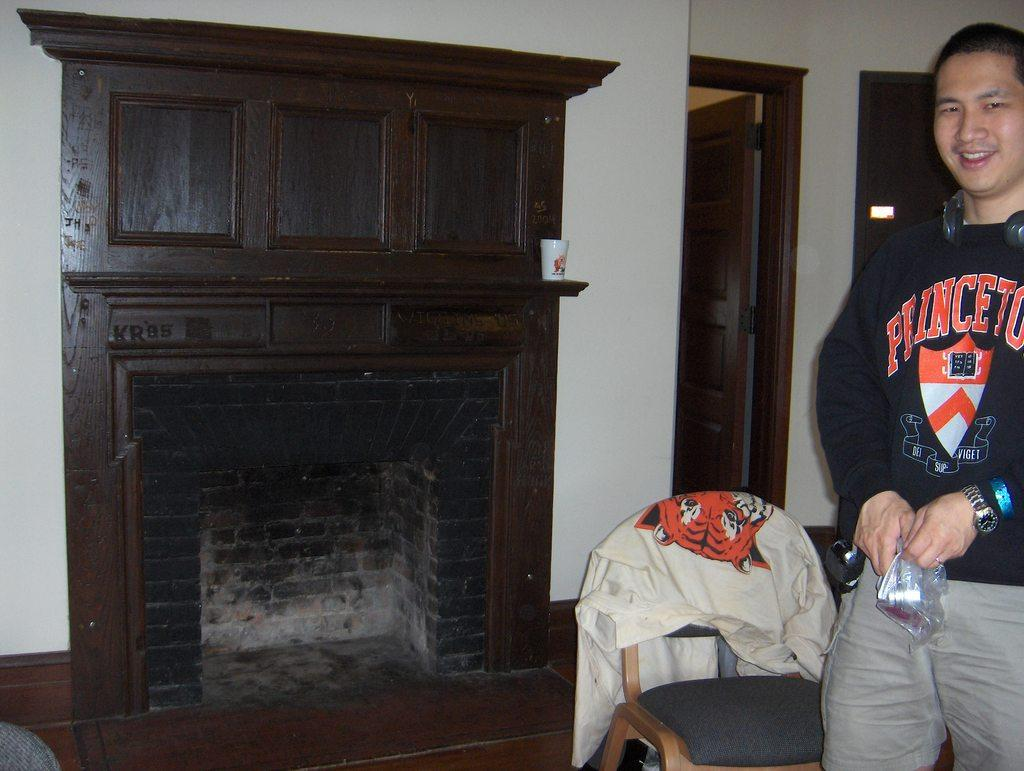What is the person in the image doing? The person is standing in the image and holding an object. Can you describe the object the person is holding? Unfortunately, the facts provided do not specify the object the person is holding. What type of furniture is present in the image? There is a chair with a cloth in the image, and a cupboard is visible in the background. What can be seen on the wall in the background? There is a door on the wall in the background. What language is the person speaking in the image? The facts provided do not mention any speech or language in the image. Is the person applying polish to the object they are holding? There is no information about the object or its condition in the image, so we cannot determine if polish is being applied. 